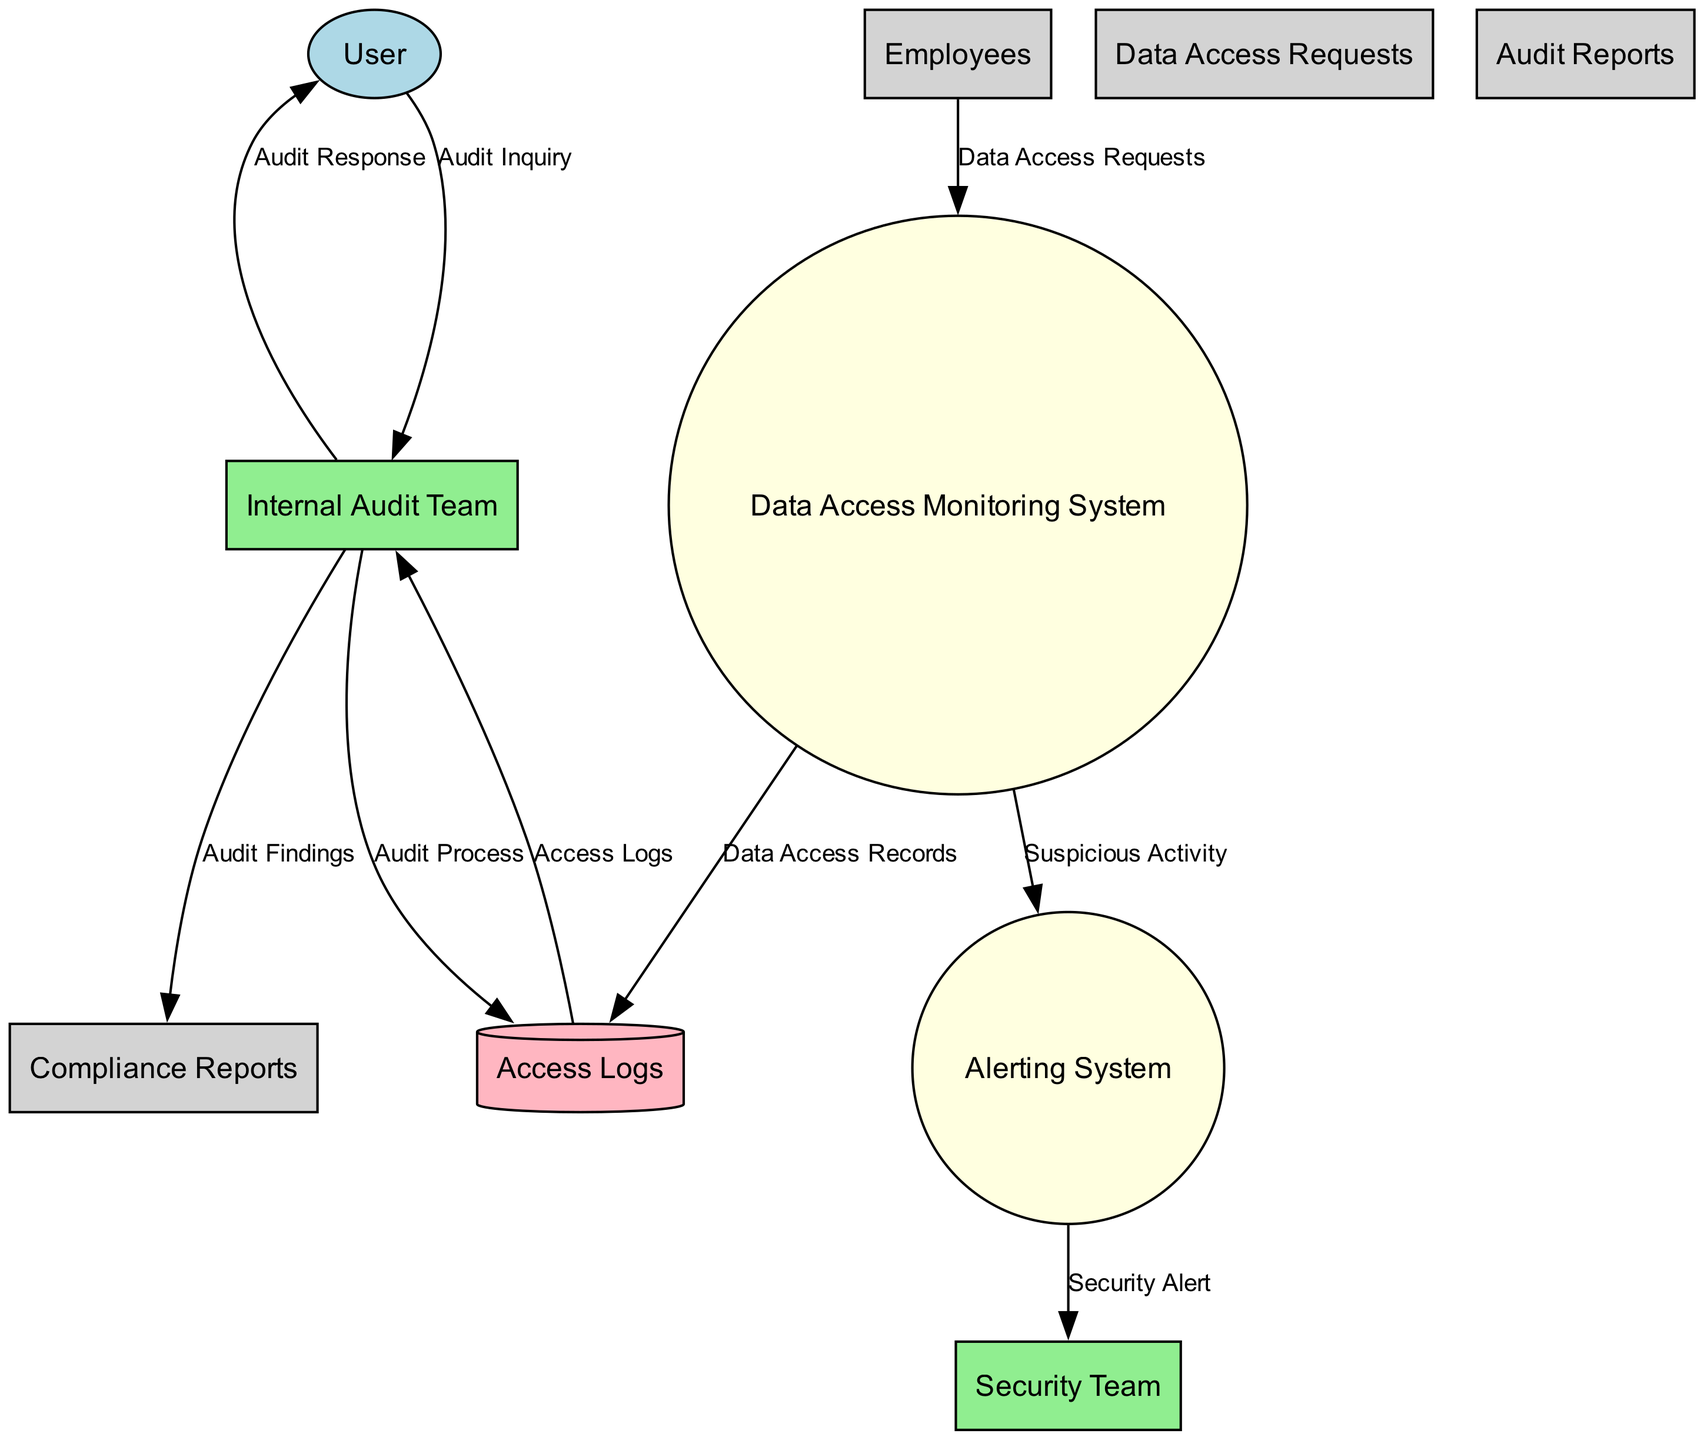What is the external entity in the diagram? The external entity is the "User," which is identified in the diagram and is noted for inquiring about the company's data protection practices.
Answer: User How many internal entities are present in the diagram? The diagram lists three internal entities: "Internal Audit Team," "Data Access Monitoring System," and "Security Team." By counting them, we find there are three.
Answer: 3 What type of data store is represented? The "Access Logs" is a data store in the diagram and is depicted as a cylinder, which denotes its function as a database storing logs of data access activities.
Answer: Access Logs What flows from the 'Internal Audit Team' to 'User'? The data flow that moves from "Internal Audit Team" to "User" is labeled "Audit Response," indicating the audit team's response to inquiries made by the user.
Answer: Audit Response What alerts the 'Security Team'? The "Alerting System" sends a "Security Alert" to the "Security Team," which is triggered by the detection of suspicious activities by the monitoring system.
Answer: Security Alert How is suspicious activity first identified? Suspicious activity is first identified by the "Data Access Monitoring System," which flags and forwards these activities to the "Alerting System" for further action.
Answer: Data Access Monitoring System What data flow links the 'Internal Audit Team' and 'Compliance Reports'? The "Audit Findings" data flow links the "Internal Audit Team" to "Compliance Reports," as it reflects the results of internal audits that are used to ensure compliance with regulations.
Answer: Audit Findings How do employees request data access? Employees submit "Data Access Requests" directly to the "Data Access Monitoring System," indicating the means by which they initiate requests for accessing internal data.
Answer: Data Access Requests What information does the 'Internal Audit Team' provide to the 'User'? The "Internal Audit Team" provides "Audit Response" to the "User," supplying information regarding the company's data access monitoring and audit findings based on the user's inquiry.
Answer: Audit Response 